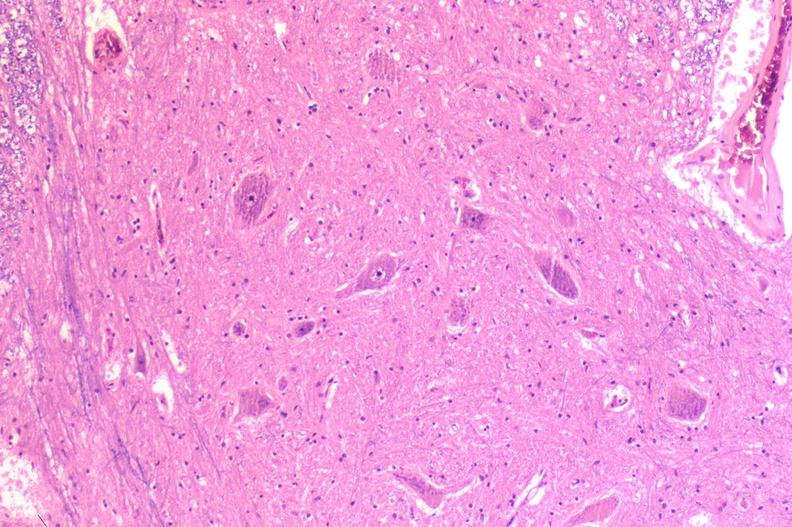s nervous present?
Answer the question using a single word or phrase. Yes 